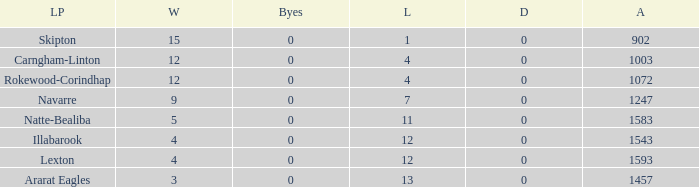What team has fewer than 9 wins and less than 1593 against? Natte-Bealiba, Illabarook, Ararat Eagles. 